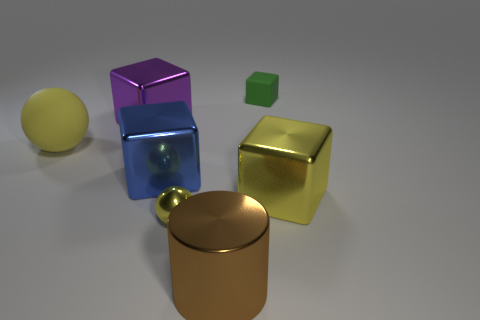Add 1 large gray rubber things. How many objects exist? 8 Subtract all cubes. How many objects are left? 3 Subtract 0 blue spheres. How many objects are left? 7 Subtract all cubes. Subtract all large purple objects. How many objects are left? 2 Add 6 tiny rubber things. How many tiny rubber things are left? 7 Add 2 tiny blue cylinders. How many tiny blue cylinders exist? 2 